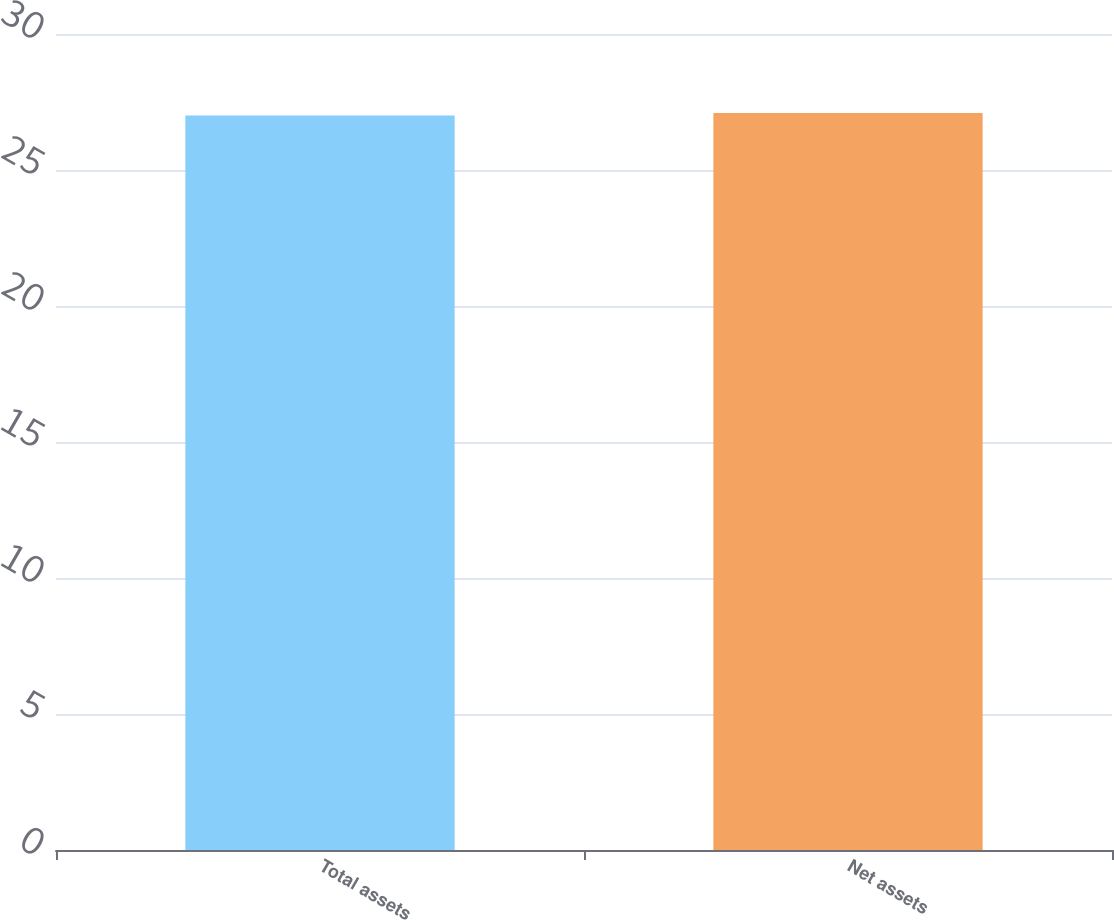<chart> <loc_0><loc_0><loc_500><loc_500><bar_chart><fcel>Total assets<fcel>Net assets<nl><fcel>27<fcel>27.1<nl></chart> 